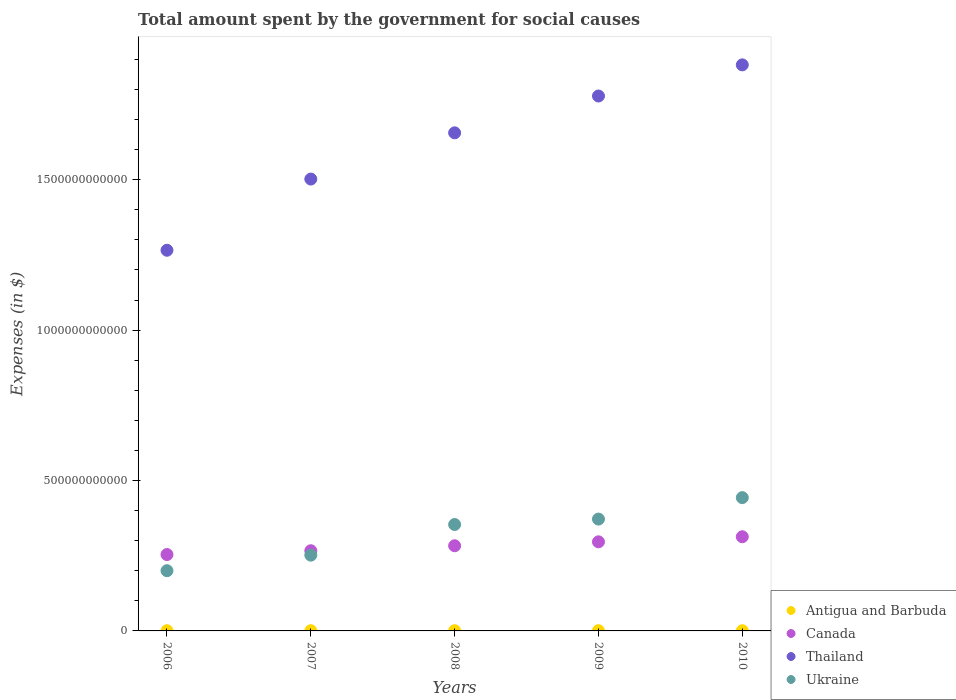How many different coloured dotlines are there?
Give a very brief answer. 4. Is the number of dotlines equal to the number of legend labels?
Keep it short and to the point. Yes. What is the amount spent for social causes by the government in Thailand in 2009?
Your response must be concise. 1.78e+12. Across all years, what is the maximum amount spent for social causes by the government in Antigua and Barbuda?
Keep it short and to the point. 7.82e+08. Across all years, what is the minimum amount spent for social causes by the government in Ukraine?
Your answer should be very brief. 2.00e+11. In which year was the amount spent for social causes by the government in Canada maximum?
Your response must be concise. 2010. In which year was the amount spent for social causes by the government in Ukraine minimum?
Offer a terse response. 2006. What is the total amount spent for social causes by the government in Canada in the graph?
Your response must be concise. 1.41e+12. What is the difference between the amount spent for social causes by the government in Ukraine in 2006 and that in 2010?
Make the answer very short. -2.43e+11. What is the difference between the amount spent for social causes by the government in Ukraine in 2006 and the amount spent for social causes by the government in Canada in 2008?
Keep it short and to the point. -8.29e+1. What is the average amount spent for social causes by the government in Thailand per year?
Give a very brief answer. 1.62e+12. In the year 2009, what is the difference between the amount spent for social causes by the government in Thailand and amount spent for social causes by the government in Canada?
Provide a succinct answer. 1.48e+12. In how many years, is the amount spent for social causes by the government in Antigua and Barbuda greater than 200000000000 $?
Keep it short and to the point. 0. What is the ratio of the amount spent for social causes by the government in Thailand in 2008 to that in 2009?
Give a very brief answer. 0.93. Is the amount spent for social causes by the government in Ukraine in 2006 less than that in 2007?
Offer a terse response. Yes. Is the difference between the amount spent for social causes by the government in Thailand in 2008 and 2010 greater than the difference between the amount spent for social causes by the government in Canada in 2008 and 2010?
Keep it short and to the point. No. What is the difference between the highest and the second highest amount spent for social causes by the government in Ukraine?
Provide a short and direct response. 7.13e+1. What is the difference between the highest and the lowest amount spent for social causes by the government in Thailand?
Provide a succinct answer. 6.16e+11. Is the sum of the amount spent for social causes by the government in Ukraine in 2006 and 2008 greater than the maximum amount spent for social causes by the government in Antigua and Barbuda across all years?
Offer a terse response. Yes. Is it the case that in every year, the sum of the amount spent for social causes by the government in Ukraine and amount spent for social causes by the government in Antigua and Barbuda  is greater than the sum of amount spent for social causes by the government in Canada and amount spent for social causes by the government in Thailand?
Ensure brevity in your answer.  No. Does the amount spent for social causes by the government in Ukraine monotonically increase over the years?
Give a very brief answer. Yes. Is the amount spent for social causes by the government in Canada strictly less than the amount spent for social causes by the government in Ukraine over the years?
Your response must be concise. No. How many dotlines are there?
Your answer should be compact. 4. What is the difference between two consecutive major ticks on the Y-axis?
Make the answer very short. 5.00e+11. How are the legend labels stacked?
Provide a short and direct response. Vertical. What is the title of the graph?
Ensure brevity in your answer.  Total amount spent by the government for social causes. What is the label or title of the X-axis?
Provide a short and direct response. Years. What is the label or title of the Y-axis?
Keep it short and to the point. Expenses (in $). What is the Expenses (in $) in Antigua and Barbuda in 2006?
Your response must be concise. 6.84e+08. What is the Expenses (in $) of Canada in 2006?
Your answer should be very brief. 2.54e+11. What is the Expenses (in $) in Thailand in 2006?
Provide a short and direct response. 1.27e+12. What is the Expenses (in $) in Ukraine in 2006?
Give a very brief answer. 2.00e+11. What is the Expenses (in $) in Antigua and Barbuda in 2007?
Your answer should be very brief. 7.50e+08. What is the Expenses (in $) in Canada in 2007?
Provide a short and direct response. 2.67e+11. What is the Expenses (in $) in Thailand in 2007?
Your answer should be compact. 1.50e+12. What is the Expenses (in $) in Ukraine in 2007?
Your response must be concise. 2.52e+11. What is the Expenses (in $) in Antigua and Barbuda in 2008?
Provide a succinct answer. 7.66e+08. What is the Expenses (in $) of Canada in 2008?
Keep it short and to the point. 2.83e+11. What is the Expenses (in $) of Thailand in 2008?
Keep it short and to the point. 1.66e+12. What is the Expenses (in $) of Ukraine in 2008?
Make the answer very short. 3.54e+11. What is the Expenses (in $) of Antigua and Barbuda in 2009?
Offer a terse response. 7.82e+08. What is the Expenses (in $) of Canada in 2009?
Make the answer very short. 2.96e+11. What is the Expenses (in $) of Thailand in 2009?
Provide a short and direct response. 1.78e+12. What is the Expenses (in $) in Ukraine in 2009?
Give a very brief answer. 3.72e+11. What is the Expenses (in $) of Antigua and Barbuda in 2010?
Offer a very short reply. 6.76e+08. What is the Expenses (in $) of Canada in 2010?
Offer a terse response. 3.13e+11. What is the Expenses (in $) of Thailand in 2010?
Ensure brevity in your answer.  1.88e+12. What is the Expenses (in $) in Ukraine in 2010?
Offer a terse response. 4.43e+11. Across all years, what is the maximum Expenses (in $) in Antigua and Barbuda?
Offer a terse response. 7.82e+08. Across all years, what is the maximum Expenses (in $) in Canada?
Your answer should be very brief. 3.13e+11. Across all years, what is the maximum Expenses (in $) of Thailand?
Provide a short and direct response. 1.88e+12. Across all years, what is the maximum Expenses (in $) of Ukraine?
Keep it short and to the point. 4.43e+11. Across all years, what is the minimum Expenses (in $) of Antigua and Barbuda?
Your answer should be compact. 6.76e+08. Across all years, what is the minimum Expenses (in $) in Canada?
Keep it short and to the point. 2.54e+11. Across all years, what is the minimum Expenses (in $) in Thailand?
Keep it short and to the point. 1.27e+12. Across all years, what is the minimum Expenses (in $) in Ukraine?
Give a very brief answer. 2.00e+11. What is the total Expenses (in $) in Antigua and Barbuda in the graph?
Provide a short and direct response. 3.66e+09. What is the total Expenses (in $) in Canada in the graph?
Make the answer very short. 1.41e+12. What is the total Expenses (in $) of Thailand in the graph?
Offer a terse response. 8.08e+12. What is the total Expenses (in $) of Ukraine in the graph?
Offer a very short reply. 1.62e+12. What is the difference between the Expenses (in $) in Antigua and Barbuda in 2006 and that in 2007?
Offer a terse response. -6.55e+07. What is the difference between the Expenses (in $) in Canada in 2006 and that in 2007?
Offer a very short reply. -1.26e+1. What is the difference between the Expenses (in $) of Thailand in 2006 and that in 2007?
Your answer should be very brief. -2.37e+11. What is the difference between the Expenses (in $) of Ukraine in 2006 and that in 2007?
Give a very brief answer. -5.17e+1. What is the difference between the Expenses (in $) of Antigua and Barbuda in 2006 and that in 2008?
Give a very brief answer. -8.22e+07. What is the difference between the Expenses (in $) in Canada in 2006 and that in 2008?
Ensure brevity in your answer.  -2.92e+1. What is the difference between the Expenses (in $) in Thailand in 2006 and that in 2008?
Keep it short and to the point. -3.90e+11. What is the difference between the Expenses (in $) in Ukraine in 2006 and that in 2008?
Make the answer very short. -1.54e+11. What is the difference between the Expenses (in $) of Antigua and Barbuda in 2006 and that in 2009?
Offer a very short reply. -9.76e+07. What is the difference between the Expenses (in $) in Canada in 2006 and that in 2009?
Offer a very short reply. -4.23e+1. What is the difference between the Expenses (in $) in Thailand in 2006 and that in 2009?
Give a very brief answer. -5.13e+11. What is the difference between the Expenses (in $) in Ukraine in 2006 and that in 2009?
Your answer should be very brief. -1.72e+11. What is the difference between the Expenses (in $) in Antigua and Barbuda in 2006 and that in 2010?
Your response must be concise. 7.90e+06. What is the difference between the Expenses (in $) in Canada in 2006 and that in 2010?
Your answer should be compact. -5.91e+1. What is the difference between the Expenses (in $) in Thailand in 2006 and that in 2010?
Your answer should be very brief. -6.16e+11. What is the difference between the Expenses (in $) of Ukraine in 2006 and that in 2010?
Your answer should be compact. -2.43e+11. What is the difference between the Expenses (in $) in Antigua and Barbuda in 2007 and that in 2008?
Offer a terse response. -1.67e+07. What is the difference between the Expenses (in $) of Canada in 2007 and that in 2008?
Provide a succinct answer. -1.66e+1. What is the difference between the Expenses (in $) of Thailand in 2007 and that in 2008?
Provide a short and direct response. -1.54e+11. What is the difference between the Expenses (in $) in Ukraine in 2007 and that in 2008?
Provide a short and direct response. -1.02e+11. What is the difference between the Expenses (in $) of Antigua and Barbuda in 2007 and that in 2009?
Make the answer very short. -3.21e+07. What is the difference between the Expenses (in $) in Canada in 2007 and that in 2009?
Keep it short and to the point. -2.96e+1. What is the difference between the Expenses (in $) of Thailand in 2007 and that in 2009?
Offer a very short reply. -2.76e+11. What is the difference between the Expenses (in $) in Ukraine in 2007 and that in 2009?
Keep it short and to the point. -1.20e+11. What is the difference between the Expenses (in $) in Antigua and Barbuda in 2007 and that in 2010?
Provide a succinct answer. 7.34e+07. What is the difference between the Expenses (in $) of Canada in 2007 and that in 2010?
Your response must be concise. -4.65e+1. What is the difference between the Expenses (in $) of Thailand in 2007 and that in 2010?
Your answer should be compact. -3.80e+11. What is the difference between the Expenses (in $) of Ukraine in 2007 and that in 2010?
Ensure brevity in your answer.  -1.91e+11. What is the difference between the Expenses (in $) in Antigua and Barbuda in 2008 and that in 2009?
Give a very brief answer. -1.54e+07. What is the difference between the Expenses (in $) in Canada in 2008 and that in 2009?
Make the answer very short. -1.31e+1. What is the difference between the Expenses (in $) of Thailand in 2008 and that in 2009?
Ensure brevity in your answer.  -1.22e+11. What is the difference between the Expenses (in $) in Ukraine in 2008 and that in 2009?
Offer a very short reply. -1.81e+1. What is the difference between the Expenses (in $) in Antigua and Barbuda in 2008 and that in 2010?
Give a very brief answer. 9.01e+07. What is the difference between the Expenses (in $) of Canada in 2008 and that in 2010?
Offer a terse response. -2.99e+1. What is the difference between the Expenses (in $) of Thailand in 2008 and that in 2010?
Ensure brevity in your answer.  -2.26e+11. What is the difference between the Expenses (in $) of Ukraine in 2008 and that in 2010?
Give a very brief answer. -8.94e+1. What is the difference between the Expenses (in $) in Antigua and Barbuda in 2009 and that in 2010?
Offer a very short reply. 1.06e+08. What is the difference between the Expenses (in $) in Canada in 2009 and that in 2010?
Your answer should be compact. -1.68e+1. What is the difference between the Expenses (in $) in Thailand in 2009 and that in 2010?
Your response must be concise. -1.04e+11. What is the difference between the Expenses (in $) in Ukraine in 2009 and that in 2010?
Your answer should be very brief. -7.13e+1. What is the difference between the Expenses (in $) of Antigua and Barbuda in 2006 and the Expenses (in $) of Canada in 2007?
Make the answer very short. -2.66e+11. What is the difference between the Expenses (in $) of Antigua and Barbuda in 2006 and the Expenses (in $) of Thailand in 2007?
Provide a short and direct response. -1.50e+12. What is the difference between the Expenses (in $) of Antigua and Barbuda in 2006 and the Expenses (in $) of Ukraine in 2007?
Your response must be concise. -2.51e+11. What is the difference between the Expenses (in $) of Canada in 2006 and the Expenses (in $) of Thailand in 2007?
Offer a very short reply. -1.25e+12. What is the difference between the Expenses (in $) of Canada in 2006 and the Expenses (in $) of Ukraine in 2007?
Your answer should be very brief. 2.02e+09. What is the difference between the Expenses (in $) of Thailand in 2006 and the Expenses (in $) of Ukraine in 2007?
Provide a succinct answer. 1.01e+12. What is the difference between the Expenses (in $) in Antigua and Barbuda in 2006 and the Expenses (in $) in Canada in 2008?
Your answer should be compact. -2.82e+11. What is the difference between the Expenses (in $) of Antigua and Barbuda in 2006 and the Expenses (in $) of Thailand in 2008?
Provide a succinct answer. -1.66e+12. What is the difference between the Expenses (in $) in Antigua and Barbuda in 2006 and the Expenses (in $) in Ukraine in 2008?
Your response must be concise. -3.53e+11. What is the difference between the Expenses (in $) in Canada in 2006 and the Expenses (in $) in Thailand in 2008?
Provide a succinct answer. -1.40e+12. What is the difference between the Expenses (in $) in Canada in 2006 and the Expenses (in $) in Ukraine in 2008?
Offer a terse response. -9.98e+1. What is the difference between the Expenses (in $) of Thailand in 2006 and the Expenses (in $) of Ukraine in 2008?
Your response must be concise. 9.12e+11. What is the difference between the Expenses (in $) in Antigua and Barbuda in 2006 and the Expenses (in $) in Canada in 2009?
Provide a succinct answer. -2.96e+11. What is the difference between the Expenses (in $) of Antigua and Barbuda in 2006 and the Expenses (in $) of Thailand in 2009?
Ensure brevity in your answer.  -1.78e+12. What is the difference between the Expenses (in $) in Antigua and Barbuda in 2006 and the Expenses (in $) in Ukraine in 2009?
Keep it short and to the point. -3.71e+11. What is the difference between the Expenses (in $) in Canada in 2006 and the Expenses (in $) in Thailand in 2009?
Offer a terse response. -1.52e+12. What is the difference between the Expenses (in $) of Canada in 2006 and the Expenses (in $) of Ukraine in 2009?
Provide a short and direct response. -1.18e+11. What is the difference between the Expenses (in $) in Thailand in 2006 and the Expenses (in $) in Ukraine in 2009?
Give a very brief answer. 8.94e+11. What is the difference between the Expenses (in $) in Antigua and Barbuda in 2006 and the Expenses (in $) in Canada in 2010?
Provide a succinct answer. -3.12e+11. What is the difference between the Expenses (in $) in Antigua and Barbuda in 2006 and the Expenses (in $) in Thailand in 2010?
Offer a terse response. -1.88e+12. What is the difference between the Expenses (in $) in Antigua and Barbuda in 2006 and the Expenses (in $) in Ukraine in 2010?
Provide a succinct answer. -4.42e+11. What is the difference between the Expenses (in $) of Canada in 2006 and the Expenses (in $) of Thailand in 2010?
Offer a terse response. -1.63e+12. What is the difference between the Expenses (in $) of Canada in 2006 and the Expenses (in $) of Ukraine in 2010?
Make the answer very short. -1.89e+11. What is the difference between the Expenses (in $) in Thailand in 2006 and the Expenses (in $) in Ukraine in 2010?
Offer a terse response. 8.22e+11. What is the difference between the Expenses (in $) in Antigua and Barbuda in 2007 and the Expenses (in $) in Canada in 2008?
Provide a short and direct response. -2.82e+11. What is the difference between the Expenses (in $) in Antigua and Barbuda in 2007 and the Expenses (in $) in Thailand in 2008?
Ensure brevity in your answer.  -1.66e+12. What is the difference between the Expenses (in $) of Antigua and Barbuda in 2007 and the Expenses (in $) of Ukraine in 2008?
Make the answer very short. -3.53e+11. What is the difference between the Expenses (in $) of Canada in 2007 and the Expenses (in $) of Thailand in 2008?
Ensure brevity in your answer.  -1.39e+12. What is the difference between the Expenses (in $) of Canada in 2007 and the Expenses (in $) of Ukraine in 2008?
Give a very brief answer. -8.72e+1. What is the difference between the Expenses (in $) in Thailand in 2007 and the Expenses (in $) in Ukraine in 2008?
Your response must be concise. 1.15e+12. What is the difference between the Expenses (in $) of Antigua and Barbuda in 2007 and the Expenses (in $) of Canada in 2009?
Your response must be concise. -2.95e+11. What is the difference between the Expenses (in $) in Antigua and Barbuda in 2007 and the Expenses (in $) in Thailand in 2009?
Offer a very short reply. -1.78e+12. What is the difference between the Expenses (in $) in Antigua and Barbuda in 2007 and the Expenses (in $) in Ukraine in 2009?
Make the answer very short. -3.71e+11. What is the difference between the Expenses (in $) of Canada in 2007 and the Expenses (in $) of Thailand in 2009?
Offer a very short reply. -1.51e+12. What is the difference between the Expenses (in $) in Canada in 2007 and the Expenses (in $) in Ukraine in 2009?
Give a very brief answer. -1.05e+11. What is the difference between the Expenses (in $) of Thailand in 2007 and the Expenses (in $) of Ukraine in 2009?
Offer a terse response. 1.13e+12. What is the difference between the Expenses (in $) in Antigua and Barbuda in 2007 and the Expenses (in $) in Canada in 2010?
Your answer should be very brief. -3.12e+11. What is the difference between the Expenses (in $) in Antigua and Barbuda in 2007 and the Expenses (in $) in Thailand in 2010?
Offer a terse response. -1.88e+12. What is the difference between the Expenses (in $) in Antigua and Barbuda in 2007 and the Expenses (in $) in Ukraine in 2010?
Your answer should be very brief. -4.42e+11. What is the difference between the Expenses (in $) of Canada in 2007 and the Expenses (in $) of Thailand in 2010?
Offer a very short reply. -1.62e+12. What is the difference between the Expenses (in $) of Canada in 2007 and the Expenses (in $) of Ukraine in 2010?
Your answer should be compact. -1.77e+11. What is the difference between the Expenses (in $) of Thailand in 2007 and the Expenses (in $) of Ukraine in 2010?
Your response must be concise. 1.06e+12. What is the difference between the Expenses (in $) in Antigua and Barbuda in 2008 and the Expenses (in $) in Canada in 2009?
Offer a terse response. -2.95e+11. What is the difference between the Expenses (in $) of Antigua and Barbuda in 2008 and the Expenses (in $) of Thailand in 2009?
Your response must be concise. -1.78e+12. What is the difference between the Expenses (in $) of Antigua and Barbuda in 2008 and the Expenses (in $) of Ukraine in 2009?
Provide a succinct answer. -3.71e+11. What is the difference between the Expenses (in $) of Canada in 2008 and the Expenses (in $) of Thailand in 2009?
Make the answer very short. -1.50e+12. What is the difference between the Expenses (in $) of Canada in 2008 and the Expenses (in $) of Ukraine in 2009?
Provide a succinct answer. -8.87e+1. What is the difference between the Expenses (in $) in Thailand in 2008 and the Expenses (in $) in Ukraine in 2009?
Give a very brief answer. 1.28e+12. What is the difference between the Expenses (in $) in Antigua and Barbuda in 2008 and the Expenses (in $) in Canada in 2010?
Make the answer very short. -3.12e+11. What is the difference between the Expenses (in $) of Antigua and Barbuda in 2008 and the Expenses (in $) of Thailand in 2010?
Ensure brevity in your answer.  -1.88e+12. What is the difference between the Expenses (in $) in Antigua and Barbuda in 2008 and the Expenses (in $) in Ukraine in 2010?
Give a very brief answer. -4.42e+11. What is the difference between the Expenses (in $) in Canada in 2008 and the Expenses (in $) in Thailand in 2010?
Your answer should be very brief. -1.60e+12. What is the difference between the Expenses (in $) of Canada in 2008 and the Expenses (in $) of Ukraine in 2010?
Offer a terse response. -1.60e+11. What is the difference between the Expenses (in $) in Thailand in 2008 and the Expenses (in $) in Ukraine in 2010?
Give a very brief answer. 1.21e+12. What is the difference between the Expenses (in $) of Antigua and Barbuda in 2009 and the Expenses (in $) of Canada in 2010?
Provide a succinct answer. -3.12e+11. What is the difference between the Expenses (in $) in Antigua and Barbuda in 2009 and the Expenses (in $) in Thailand in 2010?
Your answer should be compact. -1.88e+12. What is the difference between the Expenses (in $) in Antigua and Barbuda in 2009 and the Expenses (in $) in Ukraine in 2010?
Give a very brief answer. -4.42e+11. What is the difference between the Expenses (in $) in Canada in 2009 and the Expenses (in $) in Thailand in 2010?
Ensure brevity in your answer.  -1.59e+12. What is the difference between the Expenses (in $) in Canada in 2009 and the Expenses (in $) in Ukraine in 2010?
Make the answer very short. -1.47e+11. What is the difference between the Expenses (in $) of Thailand in 2009 and the Expenses (in $) of Ukraine in 2010?
Offer a very short reply. 1.34e+12. What is the average Expenses (in $) in Antigua and Barbuda per year?
Your answer should be very brief. 7.32e+08. What is the average Expenses (in $) in Canada per year?
Keep it short and to the point. 2.83e+11. What is the average Expenses (in $) in Thailand per year?
Your response must be concise. 1.62e+12. What is the average Expenses (in $) in Ukraine per year?
Provide a short and direct response. 3.24e+11. In the year 2006, what is the difference between the Expenses (in $) of Antigua and Barbuda and Expenses (in $) of Canada?
Give a very brief answer. -2.53e+11. In the year 2006, what is the difference between the Expenses (in $) in Antigua and Barbuda and Expenses (in $) in Thailand?
Your answer should be compact. -1.26e+12. In the year 2006, what is the difference between the Expenses (in $) of Antigua and Barbuda and Expenses (in $) of Ukraine?
Your response must be concise. -2.00e+11. In the year 2006, what is the difference between the Expenses (in $) of Canada and Expenses (in $) of Thailand?
Provide a short and direct response. -1.01e+12. In the year 2006, what is the difference between the Expenses (in $) of Canada and Expenses (in $) of Ukraine?
Your response must be concise. 5.37e+1. In the year 2006, what is the difference between the Expenses (in $) of Thailand and Expenses (in $) of Ukraine?
Your answer should be compact. 1.07e+12. In the year 2007, what is the difference between the Expenses (in $) in Antigua and Barbuda and Expenses (in $) in Canada?
Provide a succinct answer. -2.66e+11. In the year 2007, what is the difference between the Expenses (in $) of Antigua and Barbuda and Expenses (in $) of Thailand?
Give a very brief answer. -1.50e+12. In the year 2007, what is the difference between the Expenses (in $) of Antigua and Barbuda and Expenses (in $) of Ukraine?
Your response must be concise. -2.51e+11. In the year 2007, what is the difference between the Expenses (in $) in Canada and Expenses (in $) in Thailand?
Provide a short and direct response. -1.24e+12. In the year 2007, what is the difference between the Expenses (in $) of Canada and Expenses (in $) of Ukraine?
Ensure brevity in your answer.  1.47e+1. In the year 2007, what is the difference between the Expenses (in $) of Thailand and Expenses (in $) of Ukraine?
Your response must be concise. 1.25e+12. In the year 2008, what is the difference between the Expenses (in $) in Antigua and Barbuda and Expenses (in $) in Canada?
Your response must be concise. -2.82e+11. In the year 2008, what is the difference between the Expenses (in $) of Antigua and Barbuda and Expenses (in $) of Thailand?
Offer a very short reply. -1.66e+12. In the year 2008, what is the difference between the Expenses (in $) of Antigua and Barbuda and Expenses (in $) of Ukraine?
Ensure brevity in your answer.  -3.53e+11. In the year 2008, what is the difference between the Expenses (in $) in Canada and Expenses (in $) in Thailand?
Ensure brevity in your answer.  -1.37e+12. In the year 2008, what is the difference between the Expenses (in $) in Canada and Expenses (in $) in Ukraine?
Provide a short and direct response. -7.06e+1. In the year 2008, what is the difference between the Expenses (in $) of Thailand and Expenses (in $) of Ukraine?
Provide a short and direct response. 1.30e+12. In the year 2009, what is the difference between the Expenses (in $) of Antigua and Barbuda and Expenses (in $) of Canada?
Provide a succinct answer. -2.95e+11. In the year 2009, what is the difference between the Expenses (in $) in Antigua and Barbuda and Expenses (in $) in Thailand?
Offer a terse response. -1.78e+12. In the year 2009, what is the difference between the Expenses (in $) of Antigua and Barbuda and Expenses (in $) of Ukraine?
Your answer should be compact. -3.71e+11. In the year 2009, what is the difference between the Expenses (in $) of Canada and Expenses (in $) of Thailand?
Offer a very short reply. -1.48e+12. In the year 2009, what is the difference between the Expenses (in $) of Canada and Expenses (in $) of Ukraine?
Ensure brevity in your answer.  -7.56e+1. In the year 2009, what is the difference between the Expenses (in $) in Thailand and Expenses (in $) in Ukraine?
Ensure brevity in your answer.  1.41e+12. In the year 2010, what is the difference between the Expenses (in $) of Antigua and Barbuda and Expenses (in $) of Canada?
Your response must be concise. -3.12e+11. In the year 2010, what is the difference between the Expenses (in $) of Antigua and Barbuda and Expenses (in $) of Thailand?
Make the answer very short. -1.88e+12. In the year 2010, what is the difference between the Expenses (in $) in Antigua and Barbuda and Expenses (in $) in Ukraine?
Offer a terse response. -4.42e+11. In the year 2010, what is the difference between the Expenses (in $) of Canada and Expenses (in $) of Thailand?
Give a very brief answer. -1.57e+12. In the year 2010, what is the difference between the Expenses (in $) of Canada and Expenses (in $) of Ukraine?
Keep it short and to the point. -1.30e+11. In the year 2010, what is the difference between the Expenses (in $) of Thailand and Expenses (in $) of Ukraine?
Offer a very short reply. 1.44e+12. What is the ratio of the Expenses (in $) in Antigua and Barbuda in 2006 to that in 2007?
Provide a short and direct response. 0.91. What is the ratio of the Expenses (in $) in Canada in 2006 to that in 2007?
Make the answer very short. 0.95. What is the ratio of the Expenses (in $) in Thailand in 2006 to that in 2007?
Your answer should be compact. 0.84. What is the ratio of the Expenses (in $) of Ukraine in 2006 to that in 2007?
Your answer should be compact. 0.79. What is the ratio of the Expenses (in $) of Antigua and Barbuda in 2006 to that in 2008?
Your answer should be very brief. 0.89. What is the ratio of the Expenses (in $) in Canada in 2006 to that in 2008?
Provide a short and direct response. 0.9. What is the ratio of the Expenses (in $) in Thailand in 2006 to that in 2008?
Provide a succinct answer. 0.76. What is the ratio of the Expenses (in $) of Ukraine in 2006 to that in 2008?
Keep it short and to the point. 0.57. What is the ratio of the Expenses (in $) of Antigua and Barbuda in 2006 to that in 2009?
Provide a short and direct response. 0.88. What is the ratio of the Expenses (in $) of Canada in 2006 to that in 2009?
Offer a terse response. 0.86. What is the ratio of the Expenses (in $) in Thailand in 2006 to that in 2009?
Ensure brevity in your answer.  0.71. What is the ratio of the Expenses (in $) of Ukraine in 2006 to that in 2009?
Ensure brevity in your answer.  0.54. What is the ratio of the Expenses (in $) in Antigua and Barbuda in 2006 to that in 2010?
Your answer should be compact. 1.01. What is the ratio of the Expenses (in $) of Canada in 2006 to that in 2010?
Provide a short and direct response. 0.81. What is the ratio of the Expenses (in $) of Thailand in 2006 to that in 2010?
Make the answer very short. 0.67. What is the ratio of the Expenses (in $) in Ukraine in 2006 to that in 2010?
Give a very brief answer. 0.45. What is the ratio of the Expenses (in $) of Antigua and Barbuda in 2007 to that in 2008?
Offer a terse response. 0.98. What is the ratio of the Expenses (in $) in Canada in 2007 to that in 2008?
Ensure brevity in your answer.  0.94. What is the ratio of the Expenses (in $) in Thailand in 2007 to that in 2008?
Make the answer very short. 0.91. What is the ratio of the Expenses (in $) in Ukraine in 2007 to that in 2008?
Ensure brevity in your answer.  0.71. What is the ratio of the Expenses (in $) of Antigua and Barbuda in 2007 to that in 2009?
Make the answer very short. 0.96. What is the ratio of the Expenses (in $) of Canada in 2007 to that in 2009?
Provide a short and direct response. 0.9. What is the ratio of the Expenses (in $) of Thailand in 2007 to that in 2009?
Give a very brief answer. 0.84. What is the ratio of the Expenses (in $) of Ukraine in 2007 to that in 2009?
Give a very brief answer. 0.68. What is the ratio of the Expenses (in $) in Antigua and Barbuda in 2007 to that in 2010?
Your response must be concise. 1.11. What is the ratio of the Expenses (in $) of Canada in 2007 to that in 2010?
Ensure brevity in your answer.  0.85. What is the ratio of the Expenses (in $) in Thailand in 2007 to that in 2010?
Provide a succinct answer. 0.8. What is the ratio of the Expenses (in $) in Ukraine in 2007 to that in 2010?
Your answer should be compact. 0.57. What is the ratio of the Expenses (in $) of Antigua and Barbuda in 2008 to that in 2009?
Make the answer very short. 0.98. What is the ratio of the Expenses (in $) of Canada in 2008 to that in 2009?
Make the answer very short. 0.96. What is the ratio of the Expenses (in $) in Thailand in 2008 to that in 2009?
Your answer should be very brief. 0.93. What is the ratio of the Expenses (in $) of Ukraine in 2008 to that in 2009?
Provide a short and direct response. 0.95. What is the ratio of the Expenses (in $) in Antigua and Barbuda in 2008 to that in 2010?
Offer a very short reply. 1.13. What is the ratio of the Expenses (in $) of Canada in 2008 to that in 2010?
Provide a succinct answer. 0.9. What is the ratio of the Expenses (in $) in Thailand in 2008 to that in 2010?
Your answer should be very brief. 0.88. What is the ratio of the Expenses (in $) in Ukraine in 2008 to that in 2010?
Give a very brief answer. 0.8. What is the ratio of the Expenses (in $) in Antigua and Barbuda in 2009 to that in 2010?
Offer a terse response. 1.16. What is the ratio of the Expenses (in $) of Canada in 2009 to that in 2010?
Your answer should be compact. 0.95. What is the ratio of the Expenses (in $) in Thailand in 2009 to that in 2010?
Make the answer very short. 0.94. What is the ratio of the Expenses (in $) of Ukraine in 2009 to that in 2010?
Offer a very short reply. 0.84. What is the difference between the highest and the second highest Expenses (in $) of Antigua and Barbuda?
Keep it short and to the point. 1.54e+07. What is the difference between the highest and the second highest Expenses (in $) in Canada?
Your answer should be very brief. 1.68e+1. What is the difference between the highest and the second highest Expenses (in $) in Thailand?
Offer a terse response. 1.04e+11. What is the difference between the highest and the second highest Expenses (in $) in Ukraine?
Give a very brief answer. 7.13e+1. What is the difference between the highest and the lowest Expenses (in $) of Antigua and Barbuda?
Give a very brief answer. 1.06e+08. What is the difference between the highest and the lowest Expenses (in $) of Canada?
Keep it short and to the point. 5.91e+1. What is the difference between the highest and the lowest Expenses (in $) in Thailand?
Ensure brevity in your answer.  6.16e+11. What is the difference between the highest and the lowest Expenses (in $) of Ukraine?
Your answer should be very brief. 2.43e+11. 